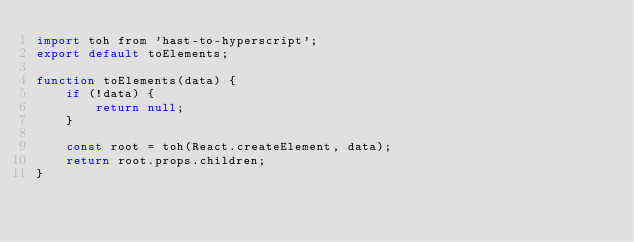Convert code to text. <code><loc_0><loc_0><loc_500><loc_500><_JavaScript_>import toh from 'hast-to-hyperscript';
export default toElements;

function toElements(data) {
	if (!data) {
		return null;
	}

	const root = toh(React.createElement, data);
	return root.props.children;
}
</code> 